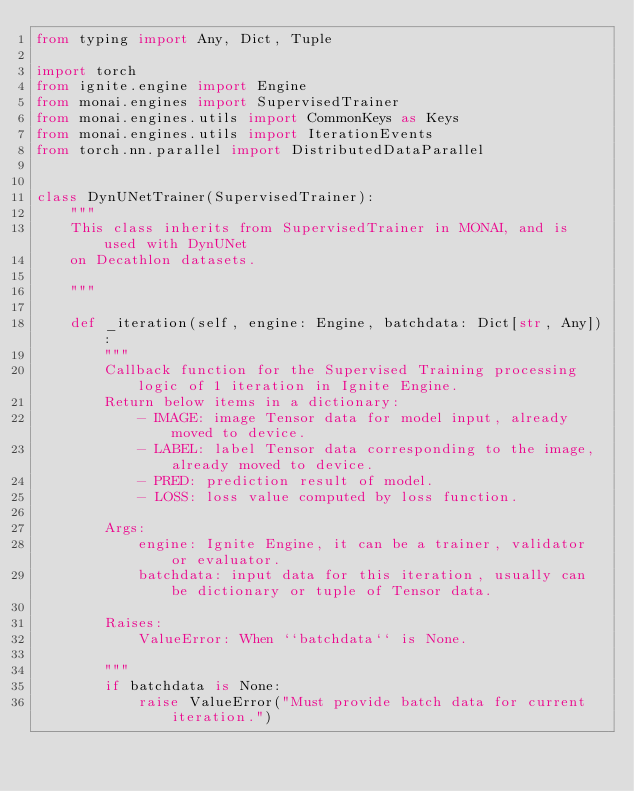<code> <loc_0><loc_0><loc_500><loc_500><_Python_>from typing import Any, Dict, Tuple

import torch
from ignite.engine import Engine
from monai.engines import SupervisedTrainer
from monai.engines.utils import CommonKeys as Keys
from monai.engines.utils import IterationEvents
from torch.nn.parallel import DistributedDataParallel


class DynUNetTrainer(SupervisedTrainer):
    """
    This class inherits from SupervisedTrainer in MONAI, and is used with DynUNet
    on Decathlon datasets.

    """

    def _iteration(self, engine: Engine, batchdata: Dict[str, Any]):
        """
        Callback function for the Supervised Training processing logic of 1 iteration in Ignite Engine.
        Return below items in a dictionary:
            - IMAGE: image Tensor data for model input, already moved to device.
            - LABEL: label Tensor data corresponding to the image, already moved to device.
            - PRED: prediction result of model.
            - LOSS: loss value computed by loss function.

        Args:
            engine: Ignite Engine, it can be a trainer, validator or evaluator.
            batchdata: input data for this iteration, usually can be dictionary or tuple of Tensor data.

        Raises:
            ValueError: When ``batchdata`` is None.

        """
        if batchdata is None:
            raise ValueError("Must provide batch data for current iteration.")</code> 